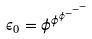Convert formula to latex. <formula><loc_0><loc_0><loc_500><loc_500>\epsilon _ { 0 } = \phi ^ { \phi ^ { \phi ^ { - ^ { - ^ { - } } } } }</formula> 